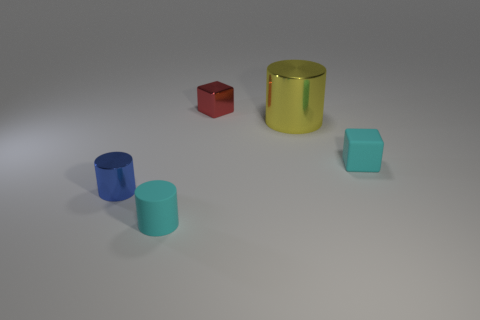Subtract all metallic cylinders. How many cylinders are left? 1 Add 5 cyan matte cylinders. How many objects exist? 10 Subtract all cubes. How many objects are left? 3 Subtract all metal cylinders. Subtract all blue things. How many objects are left? 2 Add 5 small matte objects. How many small matte objects are left? 7 Add 2 shiny cylinders. How many shiny cylinders exist? 4 Subtract 0 brown spheres. How many objects are left? 5 